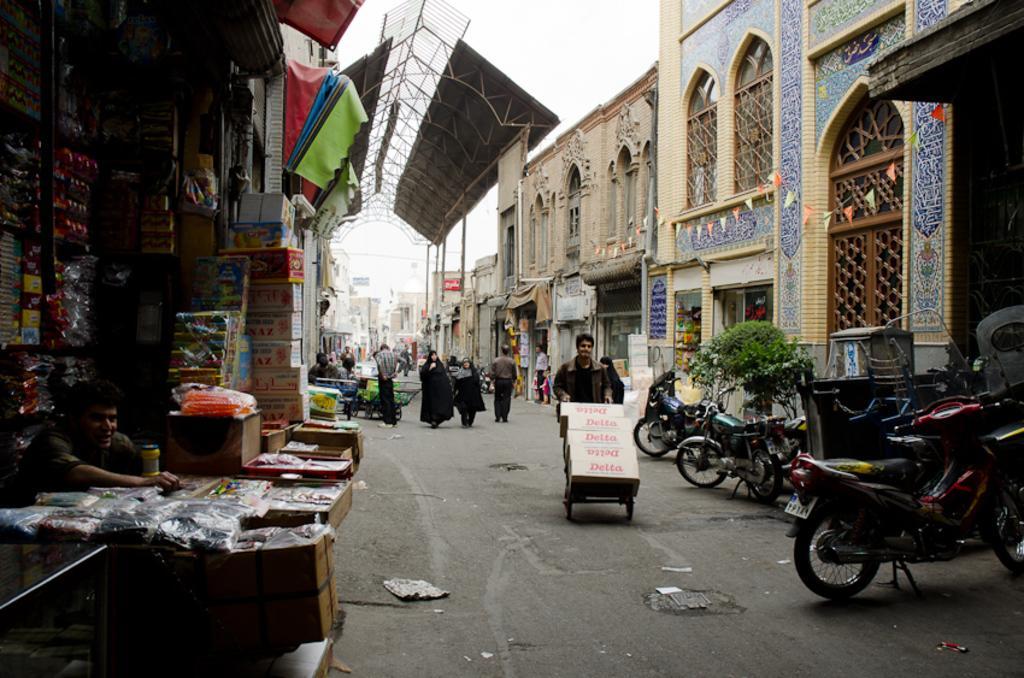In one or two sentences, can you explain what this image depicts? This image is taken outdoors. At the top of the image there is the sky. At the bottom of the image there is a road. On the left side of the image there is a stall with many things in it. A man is sitting and there are few cardboard boxes. There are a few buildings. There are many objects in the stall. On the right side of the image there are many buildings. A few bikes are parked on the road. There is a plant. In the background there are many buildings and there are a few poles. In the middle of the image a few people are walking on the road and a man is standing on the road. A man is walking on the road and he is pushing a trolley with a few objects on it. There are a few iron bars and iron sheets. 